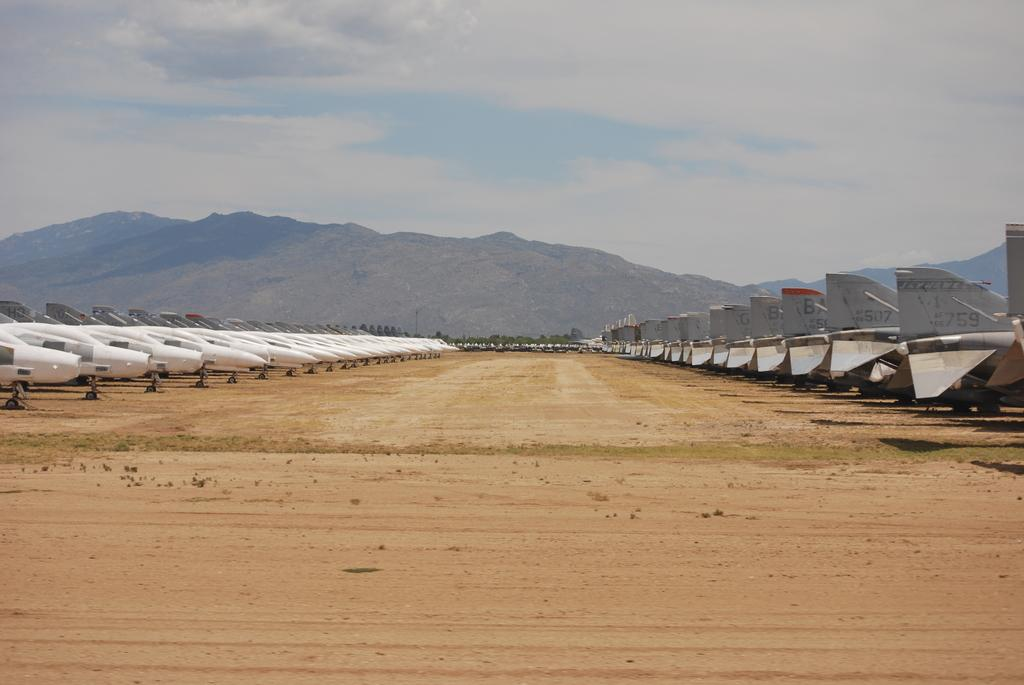What is the main subject of the image? The main subject of the image is airplanes on the ground. What can be seen in the background of the image? There are trees, mountains, and the sky visible in the background of the image. Can you tell me how many horses are grazing in the foreground of the image? There are no horses present in the image; it features airplanes on the ground with a background of trees, mountains, and the sky. 